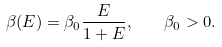<formula> <loc_0><loc_0><loc_500><loc_500>\beta ( E ) = \beta _ { 0 } \frac { E } { 1 + E } , \quad \beta _ { 0 } > 0 .</formula> 